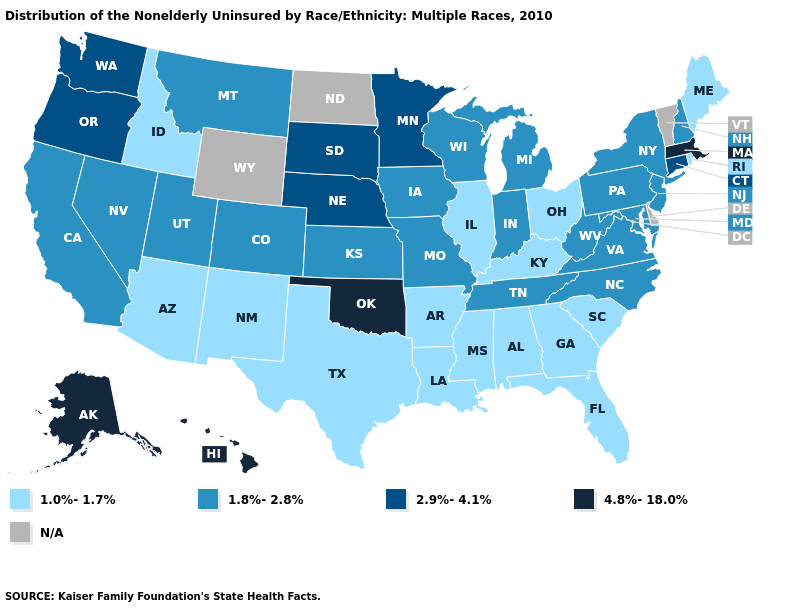What is the highest value in the MidWest ?
Answer briefly. 2.9%-4.1%. What is the lowest value in the USA?
Be succinct. 1.0%-1.7%. Name the states that have a value in the range 4.8%-18.0%?
Quick response, please. Alaska, Hawaii, Massachusetts, Oklahoma. Name the states that have a value in the range 1.8%-2.8%?
Concise answer only. California, Colorado, Indiana, Iowa, Kansas, Maryland, Michigan, Missouri, Montana, Nevada, New Hampshire, New Jersey, New York, North Carolina, Pennsylvania, Tennessee, Utah, Virginia, West Virginia, Wisconsin. What is the lowest value in the Northeast?
Short answer required. 1.0%-1.7%. What is the value of North Carolina?
Write a very short answer. 1.8%-2.8%. What is the value of Indiana?
Keep it brief. 1.8%-2.8%. Does the first symbol in the legend represent the smallest category?
Short answer required. Yes. Does the map have missing data?
Keep it brief. Yes. Name the states that have a value in the range 2.9%-4.1%?
Concise answer only. Connecticut, Minnesota, Nebraska, Oregon, South Dakota, Washington. Which states hav the highest value in the West?
Concise answer only. Alaska, Hawaii. How many symbols are there in the legend?
Write a very short answer. 5. Name the states that have a value in the range 2.9%-4.1%?
Write a very short answer. Connecticut, Minnesota, Nebraska, Oregon, South Dakota, Washington. What is the value of Kentucky?
Concise answer only. 1.0%-1.7%. Does Arkansas have the lowest value in the South?
Quick response, please. Yes. 